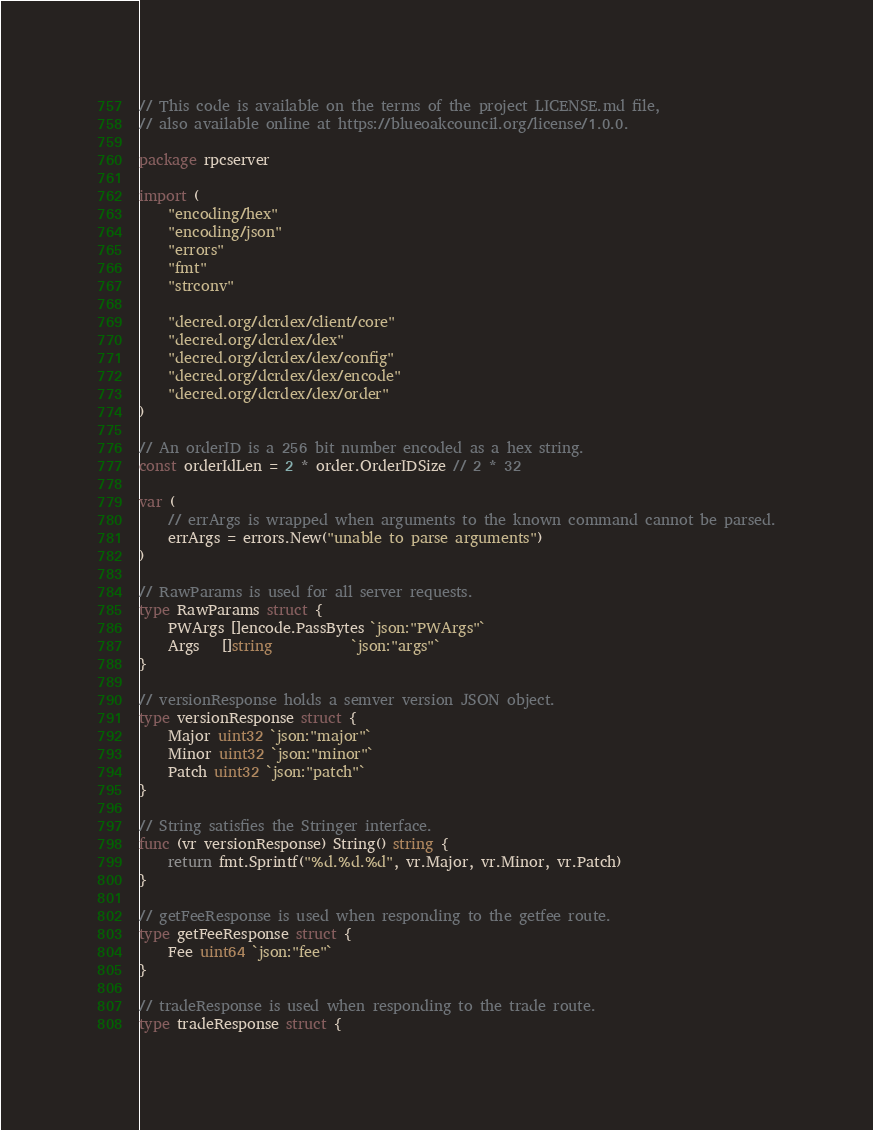Convert code to text. <code><loc_0><loc_0><loc_500><loc_500><_Go_>// This code is available on the terms of the project LICENSE.md file,
// also available online at https://blueoakcouncil.org/license/1.0.0.

package rpcserver

import (
	"encoding/hex"
	"encoding/json"
	"errors"
	"fmt"
	"strconv"

	"decred.org/dcrdex/client/core"
	"decred.org/dcrdex/dex"
	"decred.org/dcrdex/dex/config"
	"decred.org/dcrdex/dex/encode"
	"decred.org/dcrdex/dex/order"
)

// An orderID is a 256 bit number encoded as a hex string.
const orderIdLen = 2 * order.OrderIDSize // 2 * 32

var (
	// errArgs is wrapped when arguments to the known command cannot be parsed.
	errArgs = errors.New("unable to parse arguments")
)

// RawParams is used for all server requests.
type RawParams struct {
	PWArgs []encode.PassBytes `json:"PWArgs"`
	Args   []string           `json:"args"`
}

// versionResponse holds a semver version JSON object.
type versionResponse struct {
	Major uint32 `json:"major"`
	Minor uint32 `json:"minor"`
	Patch uint32 `json:"patch"`
}

// String satisfies the Stringer interface.
func (vr versionResponse) String() string {
	return fmt.Sprintf("%d.%d.%d", vr.Major, vr.Minor, vr.Patch)
}

// getFeeResponse is used when responding to the getfee route.
type getFeeResponse struct {
	Fee uint64 `json:"fee"`
}

// tradeResponse is used when responding to the trade route.
type tradeResponse struct {</code> 